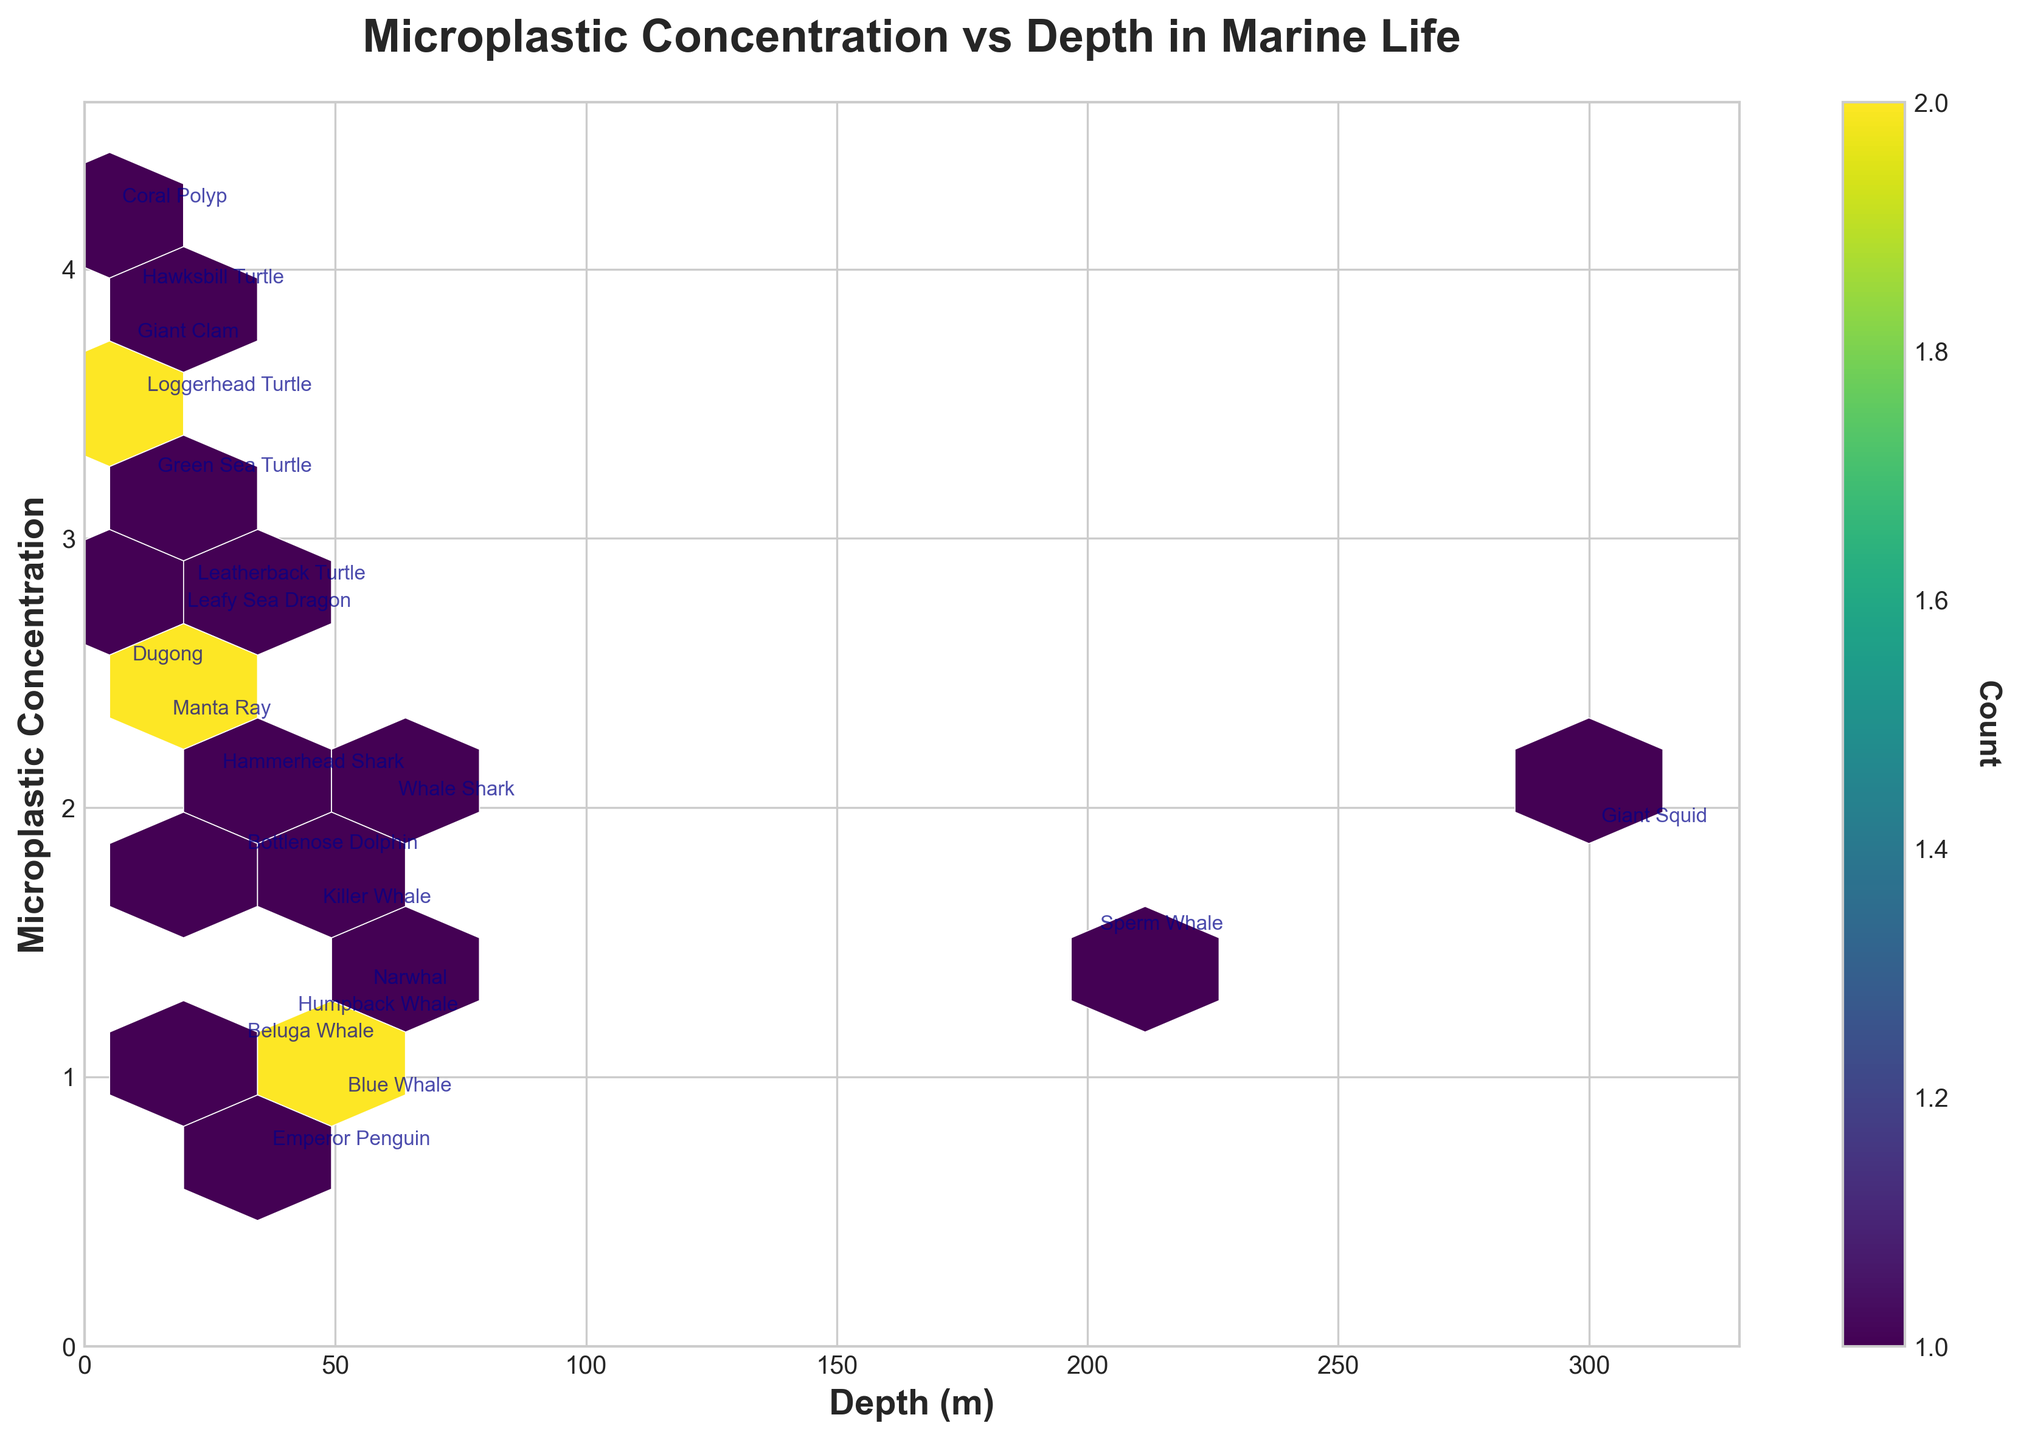What is the title of the plot? The title of a plot is usually displayed at the top of the figure. In this case, it reads "Microplastic Concentration vs Depth in Marine Life".
Answer: Microplastic Concentration vs Depth in Marine Life What are the units of measurement for the X-axis? The label for the X-axis indicates that it measures depth in meters, denoted as "(m)".
Answer: meters What does a hexagon's color represent in this plot? The color intensity of the hexagons represents the count of data points within each hexagon, which is visually displayed according to a color scale.
Answer: Count of data points Which depth range has the highest concentration of microplastics according to the plot? By observing the plot, identify the depth range where hexagons have darker colors, indicating higher counts of data points.
Answer: 5 to 20 meters How does the microplastic concentration change with increasing depth? Observing the plot shows that as depth increases, the microplastic concentration generally appears to decrease, as indicated by lighter colors in deeper hexagons.
Answer: Decreases At what depth range can you find the lowest microplastic concentrations? The lightest colored hexagons, which represent the lowest concentrations, are primarily found in deeper ranges.
Answer: 200 to 300 meters Are there more data points at shallower depths or deeper depths? By counting the number of hexagons and their color intensity, it is evident that shallower depths, particularly around 5 to 20 meters, have a higher density of data points.
Answer: Shallower depths Which species has the highest microplastic concentration? The annotation shows "Coral Polyp" at a microplastic concentration of 4.2.
Answer: Coral Polyp At approximately what depth does the highest recorded microplastic concentration occur? Look for the deepest hexagons with the highest color intensity. This is around 5 meters.
Answer: Around 5 meters Is there any correlation between depth and microplastic concentration? By examining the overall trend in the position and color of hexagons, you can observe a negative correlation, meaning the microplastic concentration typically declines with increasing depth.
Answer: Negative correlation 